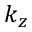<formula> <loc_0><loc_0><loc_500><loc_500>k _ { z }</formula> 